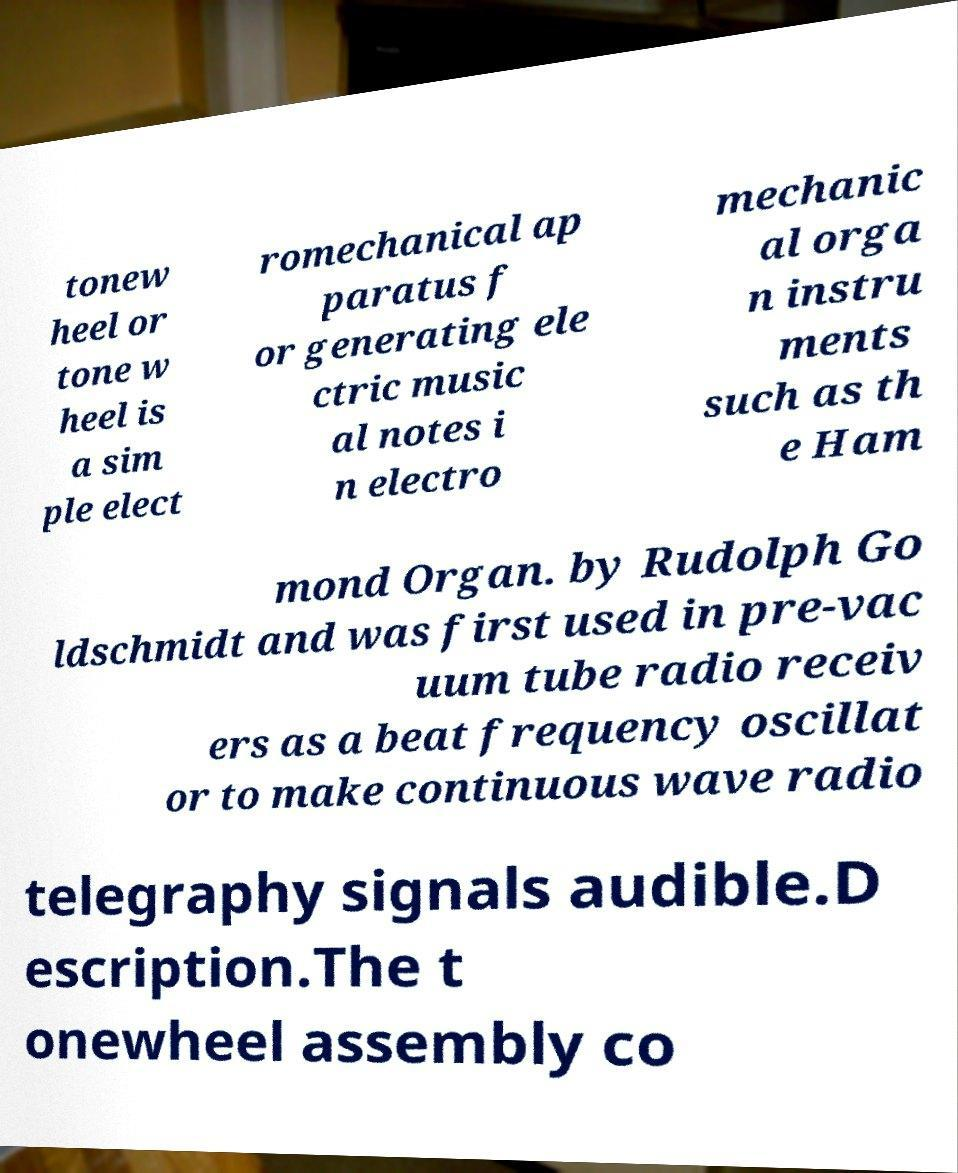Please read and relay the text visible in this image. What does it say? tonew heel or tone w heel is a sim ple elect romechanical ap paratus f or generating ele ctric music al notes i n electro mechanic al orga n instru ments such as th e Ham mond Organ. by Rudolph Go ldschmidt and was first used in pre-vac uum tube radio receiv ers as a beat frequency oscillat or to make continuous wave radio telegraphy signals audible.D escription.The t onewheel assembly co 